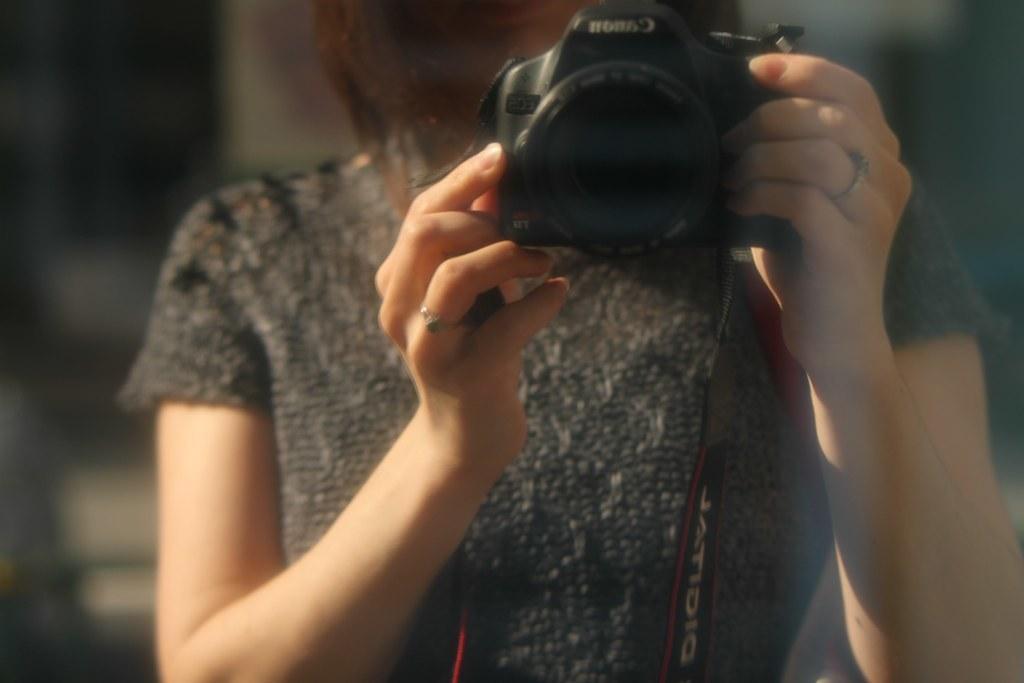How would you summarize this image in a sentence or two? In this image, we can see a person holding the camera. We can also see the blurred background. 